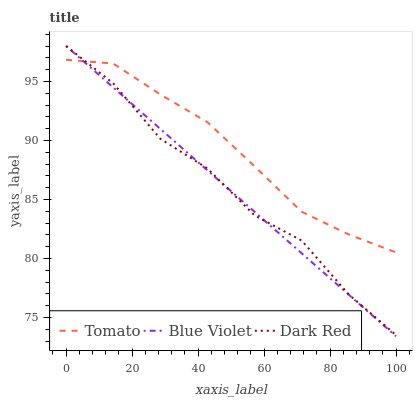Does Blue Violet have the minimum area under the curve?
Answer yes or no. Yes. Does Tomato have the maximum area under the curve?
Answer yes or no. Yes. Does Dark Red have the minimum area under the curve?
Answer yes or no. No. Does Dark Red have the maximum area under the curve?
Answer yes or no. No. Is Blue Violet the smoothest?
Answer yes or no. Yes. Is Dark Red the roughest?
Answer yes or no. Yes. Is Dark Red the smoothest?
Answer yes or no. No. Is Blue Violet the roughest?
Answer yes or no. No. Does Blue Violet have the lowest value?
Answer yes or no. Yes. Does Dark Red have the lowest value?
Answer yes or no. No. Does Blue Violet have the highest value?
Answer yes or no. Yes. Does Tomato intersect Dark Red?
Answer yes or no. Yes. Is Tomato less than Dark Red?
Answer yes or no. No. Is Tomato greater than Dark Red?
Answer yes or no. No. 